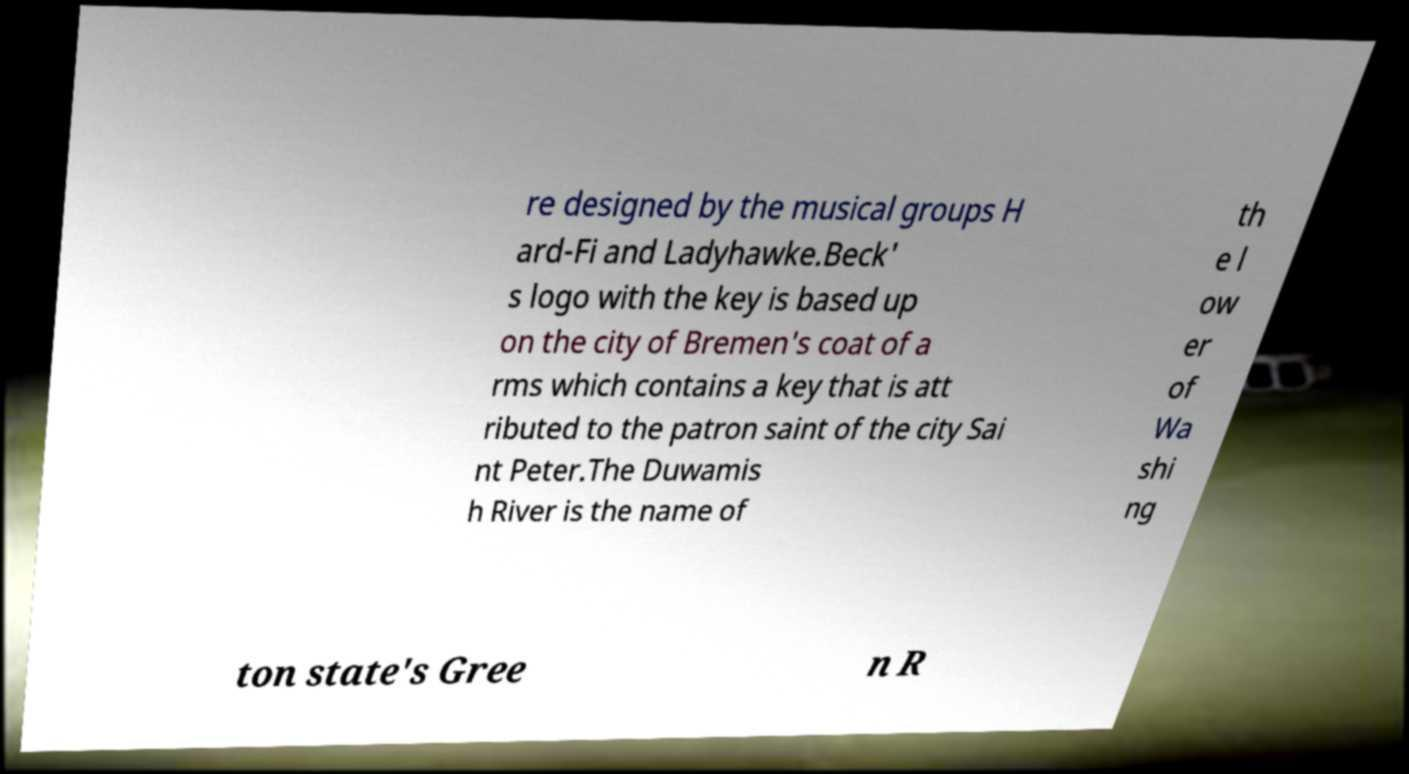Please identify and transcribe the text found in this image. re designed by the musical groups H ard-Fi and Ladyhawke.Beck' s logo with the key is based up on the city of Bremen's coat of a rms which contains a key that is att ributed to the patron saint of the city Sai nt Peter.The Duwamis h River is the name of th e l ow er of Wa shi ng ton state's Gree n R 